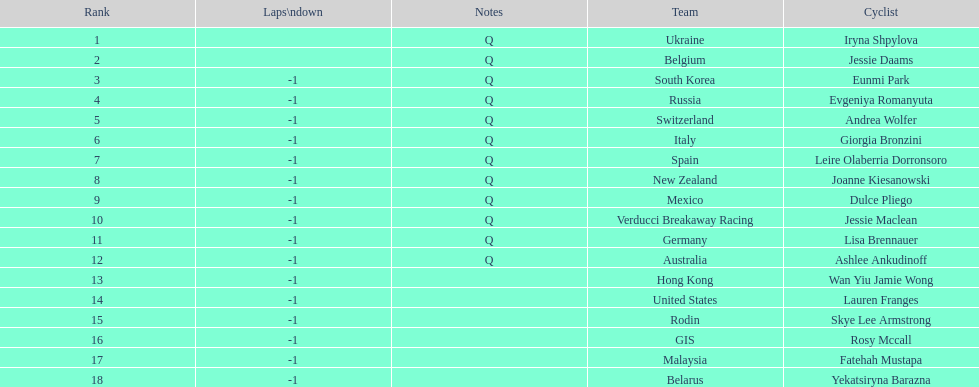Who are all of the cyclists in this race? Iryna Shpylova, Jessie Daams, Eunmi Park, Evgeniya Romanyuta, Andrea Wolfer, Giorgia Bronzini, Leire Olaberria Dorronsoro, Joanne Kiesanowski, Dulce Pliego, Jessie Maclean, Lisa Brennauer, Ashlee Ankudinoff, Wan Yiu Jamie Wong, Lauren Franges, Skye Lee Armstrong, Rosy Mccall, Fatehah Mustapa, Yekatsiryna Barazna. Of these, which one has the lowest numbered rank? Iryna Shpylova. 